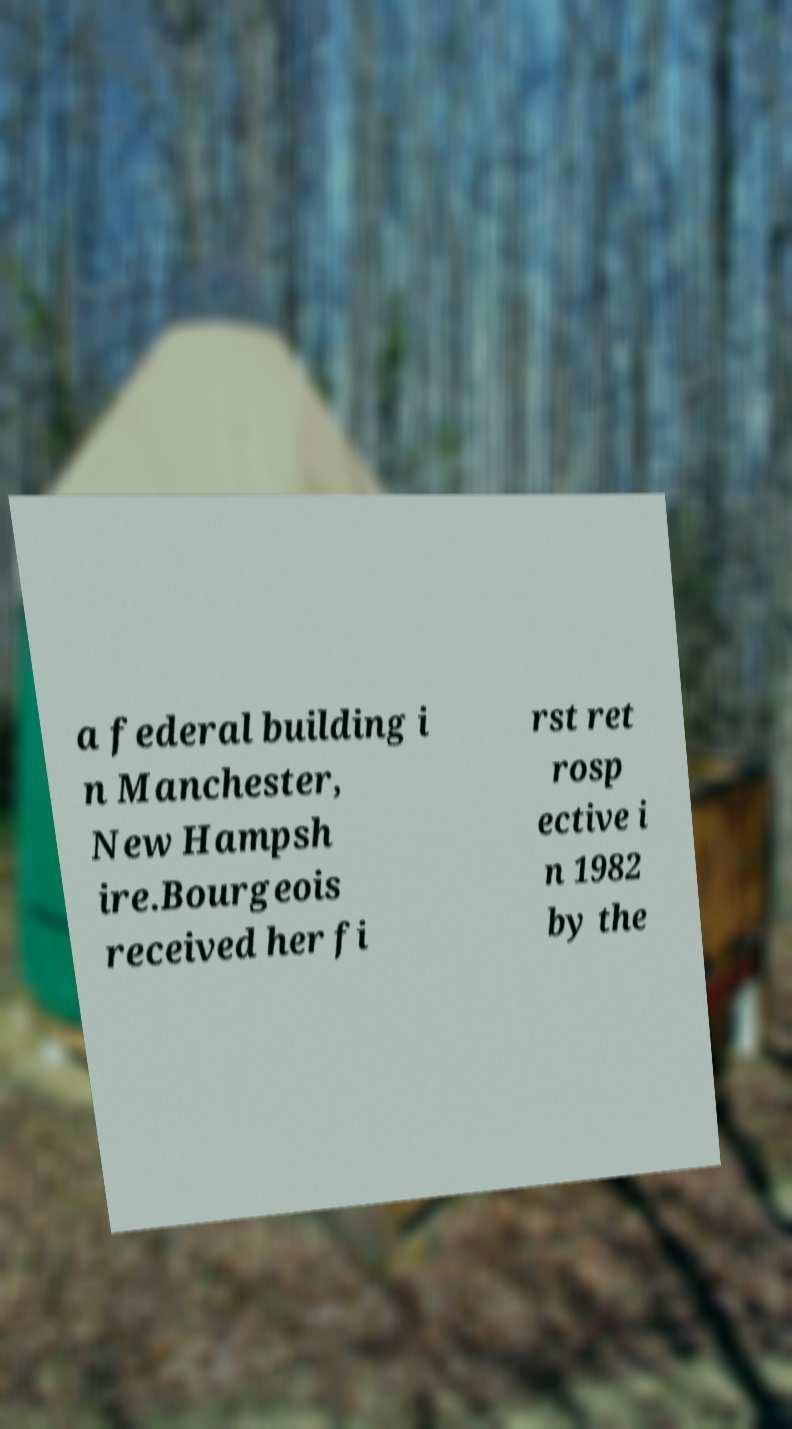Can you read and provide the text displayed in the image?This photo seems to have some interesting text. Can you extract and type it out for me? a federal building i n Manchester, New Hampsh ire.Bourgeois received her fi rst ret rosp ective i n 1982 by the 